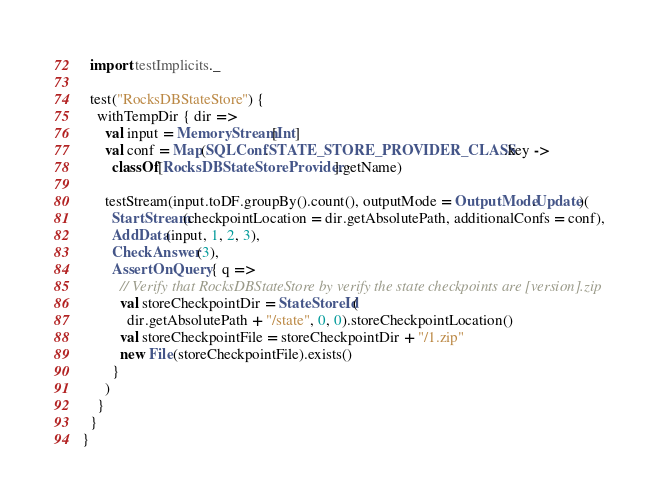<code> <loc_0><loc_0><loc_500><loc_500><_Scala_>  import testImplicits._

  test("RocksDBStateStore") {
    withTempDir { dir =>
      val input = MemoryStream[Int]
      val conf = Map(SQLConf.STATE_STORE_PROVIDER_CLASS.key ->
        classOf[RocksDBStateStoreProvider].getName)

      testStream(input.toDF.groupBy().count(), outputMode = OutputMode.Update)(
        StartStream(checkpointLocation = dir.getAbsolutePath, additionalConfs = conf),
        AddData(input, 1, 2, 3),
        CheckAnswer(3),
        AssertOnQuery { q =>
          // Verify that RocksDBStateStore by verify the state checkpoints are [version].zip
          val storeCheckpointDir = StateStoreId(
            dir.getAbsolutePath + "/state", 0, 0).storeCheckpointLocation()
          val storeCheckpointFile = storeCheckpointDir + "/1.zip"
          new File(storeCheckpointFile).exists()
        }
      )
    }
  }
}

</code> 